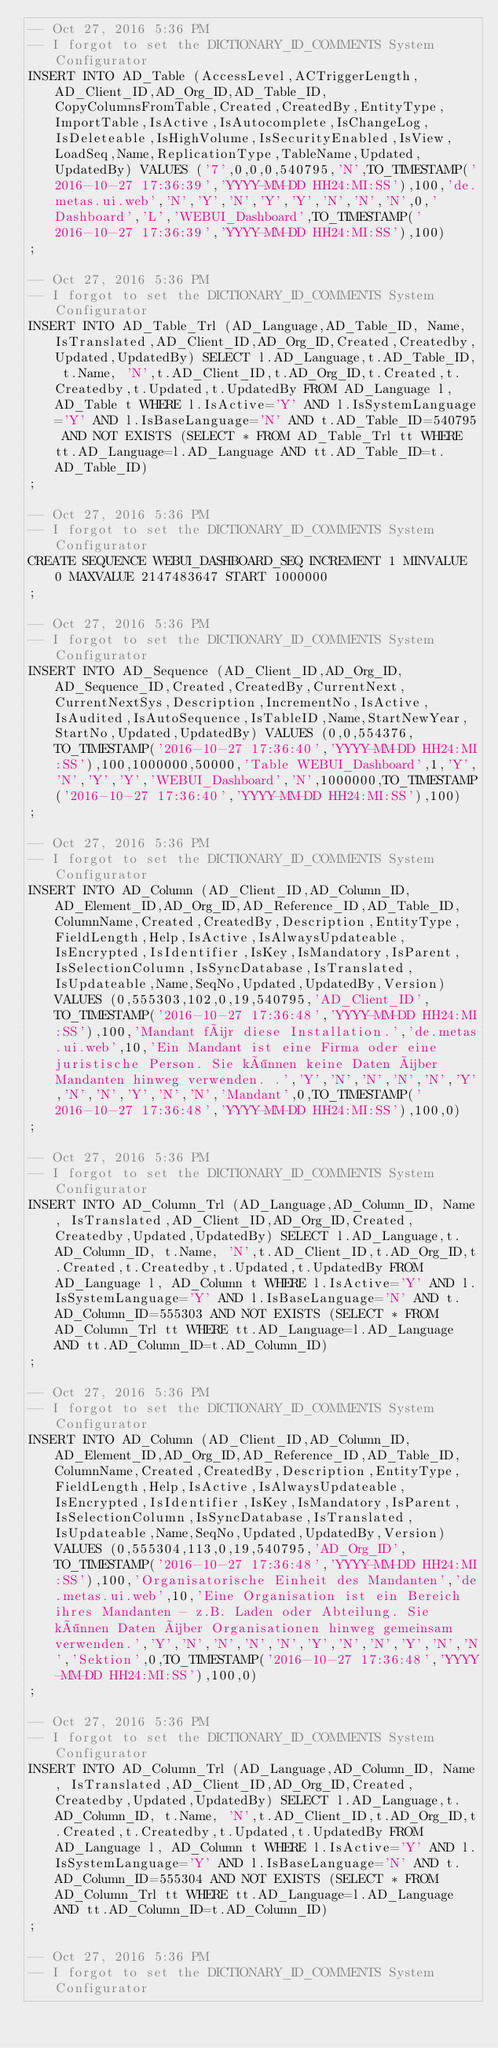<code> <loc_0><loc_0><loc_500><loc_500><_SQL_>-- Oct 27, 2016 5:36 PM
-- I forgot to set the DICTIONARY_ID_COMMENTS System Configurator
INSERT INTO AD_Table (AccessLevel,ACTriggerLength,AD_Client_ID,AD_Org_ID,AD_Table_ID,CopyColumnsFromTable,Created,CreatedBy,EntityType,ImportTable,IsActive,IsAutocomplete,IsChangeLog,IsDeleteable,IsHighVolume,IsSecurityEnabled,IsView,LoadSeq,Name,ReplicationType,TableName,Updated,UpdatedBy) VALUES ('7',0,0,0,540795,'N',TO_TIMESTAMP('2016-10-27 17:36:39','YYYY-MM-DD HH24:MI:SS'),100,'de.metas.ui.web','N','Y','N','Y','Y','N','N','N',0,'Dashboard','L','WEBUI_Dashboard',TO_TIMESTAMP('2016-10-27 17:36:39','YYYY-MM-DD HH24:MI:SS'),100)
;

-- Oct 27, 2016 5:36 PM
-- I forgot to set the DICTIONARY_ID_COMMENTS System Configurator
INSERT INTO AD_Table_Trl (AD_Language,AD_Table_ID, Name, IsTranslated,AD_Client_ID,AD_Org_ID,Created,Createdby,Updated,UpdatedBy) SELECT l.AD_Language,t.AD_Table_ID, t.Name, 'N',t.AD_Client_ID,t.AD_Org_ID,t.Created,t.Createdby,t.Updated,t.UpdatedBy FROM AD_Language l, AD_Table t WHERE l.IsActive='Y' AND l.IsSystemLanguage='Y' AND l.IsBaseLanguage='N' AND t.AD_Table_ID=540795 AND NOT EXISTS (SELECT * FROM AD_Table_Trl tt WHERE tt.AD_Language=l.AD_Language AND tt.AD_Table_ID=t.AD_Table_ID)
;

-- Oct 27, 2016 5:36 PM
-- I forgot to set the DICTIONARY_ID_COMMENTS System Configurator
CREATE SEQUENCE WEBUI_DASHBOARD_SEQ INCREMENT 1 MINVALUE 0 MAXVALUE 2147483647 START 1000000
;

-- Oct 27, 2016 5:36 PM
-- I forgot to set the DICTIONARY_ID_COMMENTS System Configurator
INSERT INTO AD_Sequence (AD_Client_ID,AD_Org_ID,AD_Sequence_ID,Created,CreatedBy,CurrentNext,CurrentNextSys,Description,IncrementNo,IsActive,IsAudited,IsAutoSequence,IsTableID,Name,StartNewYear,StartNo,Updated,UpdatedBy) VALUES (0,0,554376,TO_TIMESTAMP('2016-10-27 17:36:40','YYYY-MM-DD HH24:MI:SS'),100,1000000,50000,'Table WEBUI_Dashboard',1,'Y','N','Y','Y','WEBUI_Dashboard','N',1000000,TO_TIMESTAMP('2016-10-27 17:36:40','YYYY-MM-DD HH24:MI:SS'),100)
;

-- Oct 27, 2016 5:36 PM
-- I forgot to set the DICTIONARY_ID_COMMENTS System Configurator
INSERT INTO AD_Column (AD_Client_ID,AD_Column_ID,AD_Element_ID,AD_Org_ID,AD_Reference_ID,AD_Table_ID,ColumnName,Created,CreatedBy,Description,EntityType,FieldLength,Help,IsActive,IsAlwaysUpdateable,IsEncrypted,IsIdentifier,IsKey,IsMandatory,IsParent,IsSelectionColumn,IsSyncDatabase,IsTranslated,IsUpdateable,Name,SeqNo,Updated,UpdatedBy,Version) VALUES (0,555303,102,0,19,540795,'AD_Client_ID',TO_TIMESTAMP('2016-10-27 17:36:48','YYYY-MM-DD HH24:MI:SS'),100,'Mandant für diese Installation.','de.metas.ui.web',10,'Ein Mandant ist eine Firma oder eine juristische Person. Sie können keine Daten über Mandanten hinweg verwenden. .','Y','N','N','N','N','Y','N','N','Y','N','N','Mandant',0,TO_TIMESTAMP('2016-10-27 17:36:48','YYYY-MM-DD HH24:MI:SS'),100,0)
;

-- Oct 27, 2016 5:36 PM
-- I forgot to set the DICTIONARY_ID_COMMENTS System Configurator
INSERT INTO AD_Column_Trl (AD_Language,AD_Column_ID, Name, IsTranslated,AD_Client_ID,AD_Org_ID,Created,Createdby,Updated,UpdatedBy) SELECT l.AD_Language,t.AD_Column_ID, t.Name, 'N',t.AD_Client_ID,t.AD_Org_ID,t.Created,t.Createdby,t.Updated,t.UpdatedBy FROM AD_Language l, AD_Column t WHERE l.IsActive='Y' AND l.IsSystemLanguage='Y' AND l.IsBaseLanguage='N' AND t.AD_Column_ID=555303 AND NOT EXISTS (SELECT * FROM AD_Column_Trl tt WHERE tt.AD_Language=l.AD_Language AND tt.AD_Column_ID=t.AD_Column_ID)
;

-- Oct 27, 2016 5:36 PM
-- I forgot to set the DICTIONARY_ID_COMMENTS System Configurator
INSERT INTO AD_Column (AD_Client_ID,AD_Column_ID,AD_Element_ID,AD_Org_ID,AD_Reference_ID,AD_Table_ID,ColumnName,Created,CreatedBy,Description,EntityType,FieldLength,Help,IsActive,IsAlwaysUpdateable,IsEncrypted,IsIdentifier,IsKey,IsMandatory,IsParent,IsSelectionColumn,IsSyncDatabase,IsTranslated,IsUpdateable,Name,SeqNo,Updated,UpdatedBy,Version) VALUES (0,555304,113,0,19,540795,'AD_Org_ID',TO_TIMESTAMP('2016-10-27 17:36:48','YYYY-MM-DD HH24:MI:SS'),100,'Organisatorische Einheit des Mandanten','de.metas.ui.web',10,'Eine Organisation ist ein Bereich ihres Mandanten - z.B. Laden oder Abteilung. Sie können Daten über Organisationen hinweg gemeinsam verwenden.','Y','N','N','N','N','Y','N','N','Y','N','N','Sektion',0,TO_TIMESTAMP('2016-10-27 17:36:48','YYYY-MM-DD HH24:MI:SS'),100,0)
;

-- Oct 27, 2016 5:36 PM
-- I forgot to set the DICTIONARY_ID_COMMENTS System Configurator
INSERT INTO AD_Column_Trl (AD_Language,AD_Column_ID, Name, IsTranslated,AD_Client_ID,AD_Org_ID,Created,Createdby,Updated,UpdatedBy) SELECT l.AD_Language,t.AD_Column_ID, t.Name, 'N',t.AD_Client_ID,t.AD_Org_ID,t.Created,t.Createdby,t.Updated,t.UpdatedBy FROM AD_Language l, AD_Column t WHERE l.IsActive='Y' AND l.IsSystemLanguage='Y' AND l.IsBaseLanguage='N' AND t.AD_Column_ID=555304 AND NOT EXISTS (SELECT * FROM AD_Column_Trl tt WHERE tt.AD_Language=l.AD_Language AND tt.AD_Column_ID=t.AD_Column_ID)
;

-- Oct 27, 2016 5:36 PM
-- I forgot to set the DICTIONARY_ID_COMMENTS System Configurator</code> 